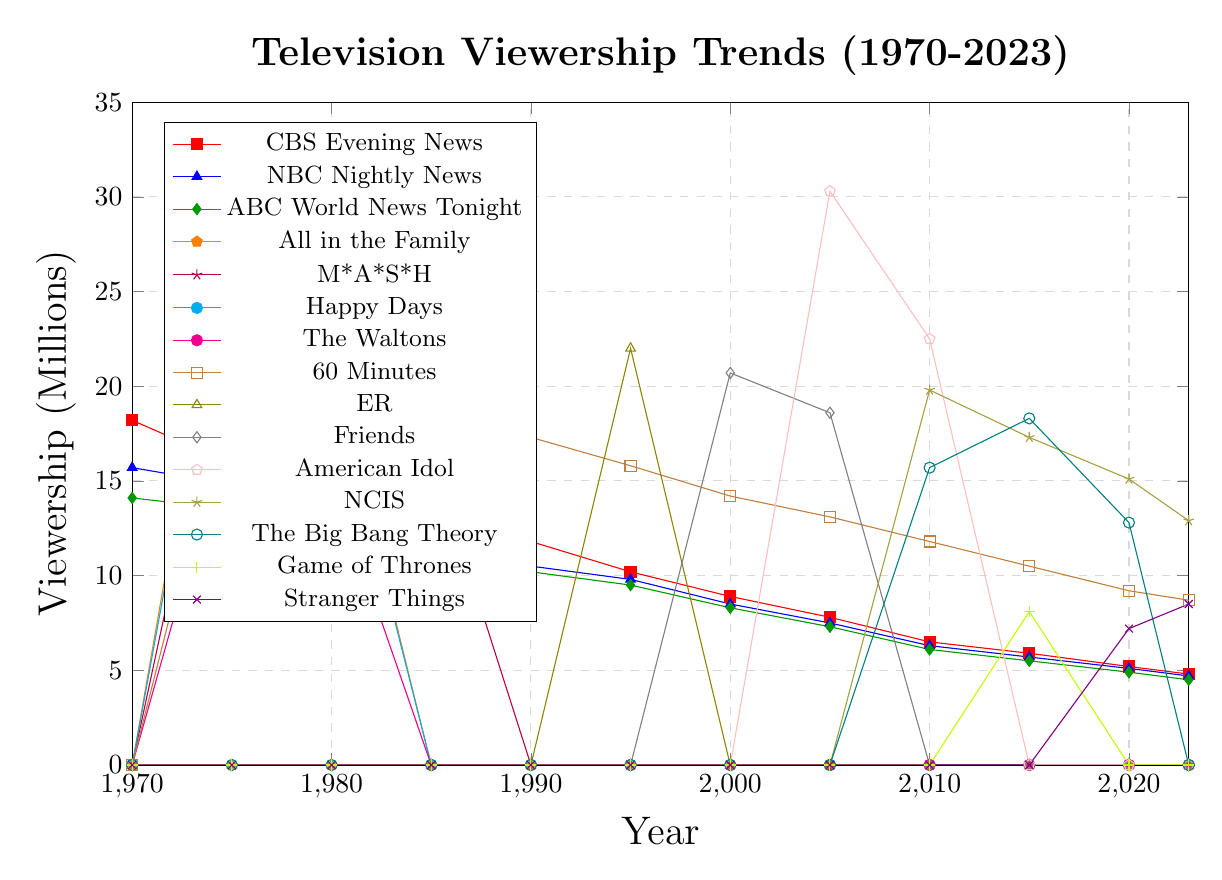Which show had the highest peak viewership? According to the chart, each line represents the viewership trend for various shows. The show with the highest peak viewership can be identified by the highest point across all lines. "All in the Family" reached a peak of 30.1 million viewers in 1975.
Answer: "All in the Family" Which news program saw the biggest decline in viewership from 1970 to 2023? To determine the biggest decline, we calculate the difference between the initial and final viewership numbers for each news program. The biggest decline is found by subtracting the 2023 viewership from the 1970 viewership for each program. CBS Evening News: 18.2 - 4.8 = 13.4; NBC Nightly News: 15.7 - 4.7 = 11; ABC World News Tonight: 14.1 - 4.5 = 9.6. Therefore, CBS Evening News saw the biggest decline.
Answer: CBS Evening News How did the viewership of "Friends" compare to "ER" in 1995? Locate the viewership numbers for both shows in 1995 from the chart. "ER" had a viewership of 22.0 million, and "Friends" is not listed in 1995. This means only ER had a notable viewership point in that year.
Answer: "ER" had more viewership; "Friends" not listed What is the trend in viewership for "60 Minutes" from 1975 to 2023? Identify the points on the chart corresponding to "60 Minutes" from 1975 to 2023. In 1975, "60 Minutes" had 20.8 million viewers. In subsequent years: 22.5 (1980), 19.7 (1985), 17.3 (1990), 15.8 (1995), 14.2 (2000), 13.1 (2005), 11.8 (2010), 10.5 (2015), 9.2 (2020), 8.7 (2023). The trend shows a gradual decline in viewership over the years.
Answer: Gradual decline What was the viewership of "NCIS" in 2015 and how does it compare to "American Idol" in 2005? Identify the viewership for "NCIS" in 2015 and "American Idol" in 2005 from the chart. "NCIS" had 17.3 million viewers in 2015, and "American Idol" had 30.3 million viewers in 2005. So, "American Idol" had significantly higher viewership.
Answer: "American Idol" had higher viewership Which show first appeared on the chart after 2000 and had a viewership greater than 15 million? By examining the chart for shows appearing after 2000 and exceeding 15 million viewers, we see "American Idol" (2005 with 30.3 million viewers) and "NCIS" (2010 with 19.8 million viewers) achieved this.
Answer: "American Idol" and "NCIS" For the news programs, which decade saw the steepest decline in total combined viewership? Calculate the total combined viewership of CBS Evening News, NBC Nightly News, and ABC World News Tonight for each decade and find the difference between consecutive decades. Steepest decline: 1970s to 1980s: (48-40.1)=7.9, 1980s to 1990s: (37.1-32.5)=4.6, 1990s to 2000s: (28.5-26)=2.5, 2000s to 2010s: (20.6-15.9)=4.7, 2010s to 2020s: (15.5-14)=1.5. The 1970s to 1980s had the steepest decline.
Answer: 1970s to 1980s 